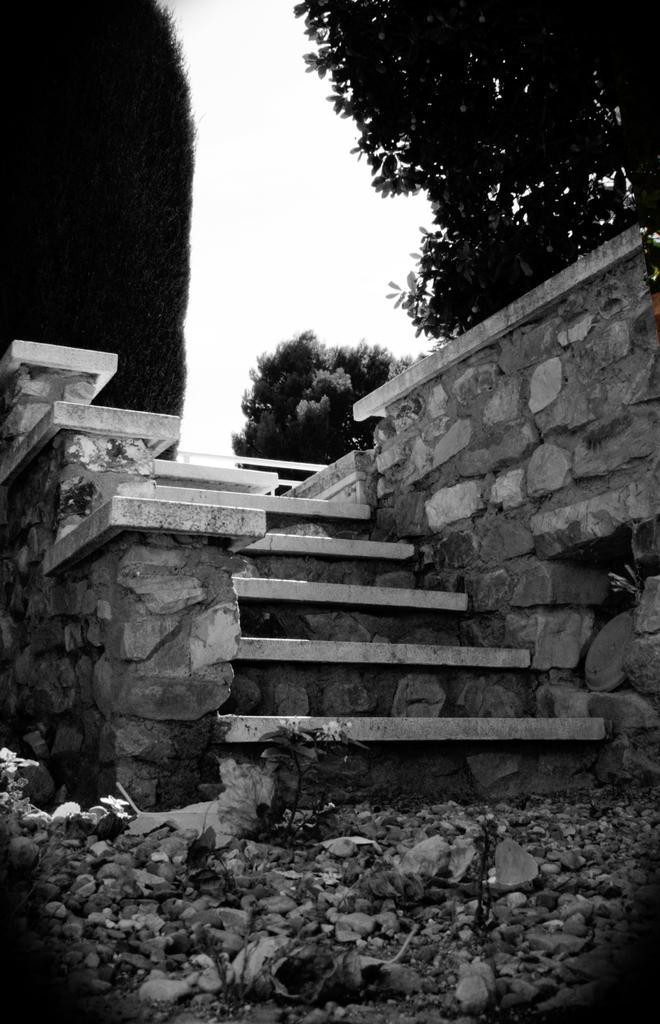Describe this image in one or two sentences. This is a black and white image. In this image, in the middle, we can see a staircase. On the right side, we can see a wall which is made of stones, trees. On the left side, we can also see some trees. At the top, we can see a sky, at the bottom, we can see a land with some stones. 